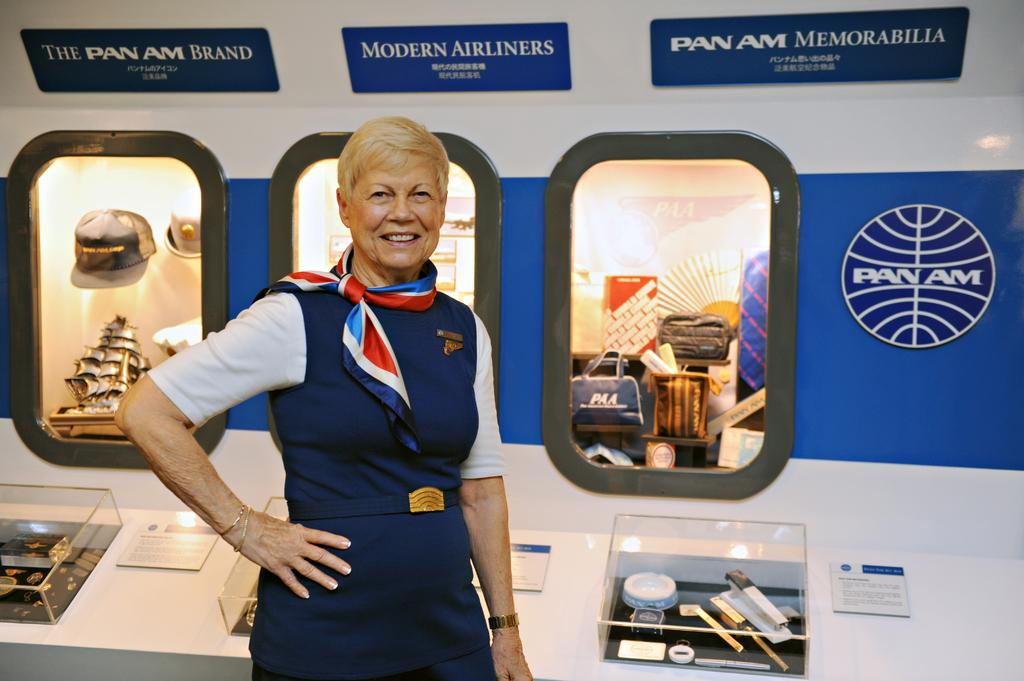<image>
Describe the image concisely. A woman in a flight attendant uniform stands next to a Pan Am historical display. 